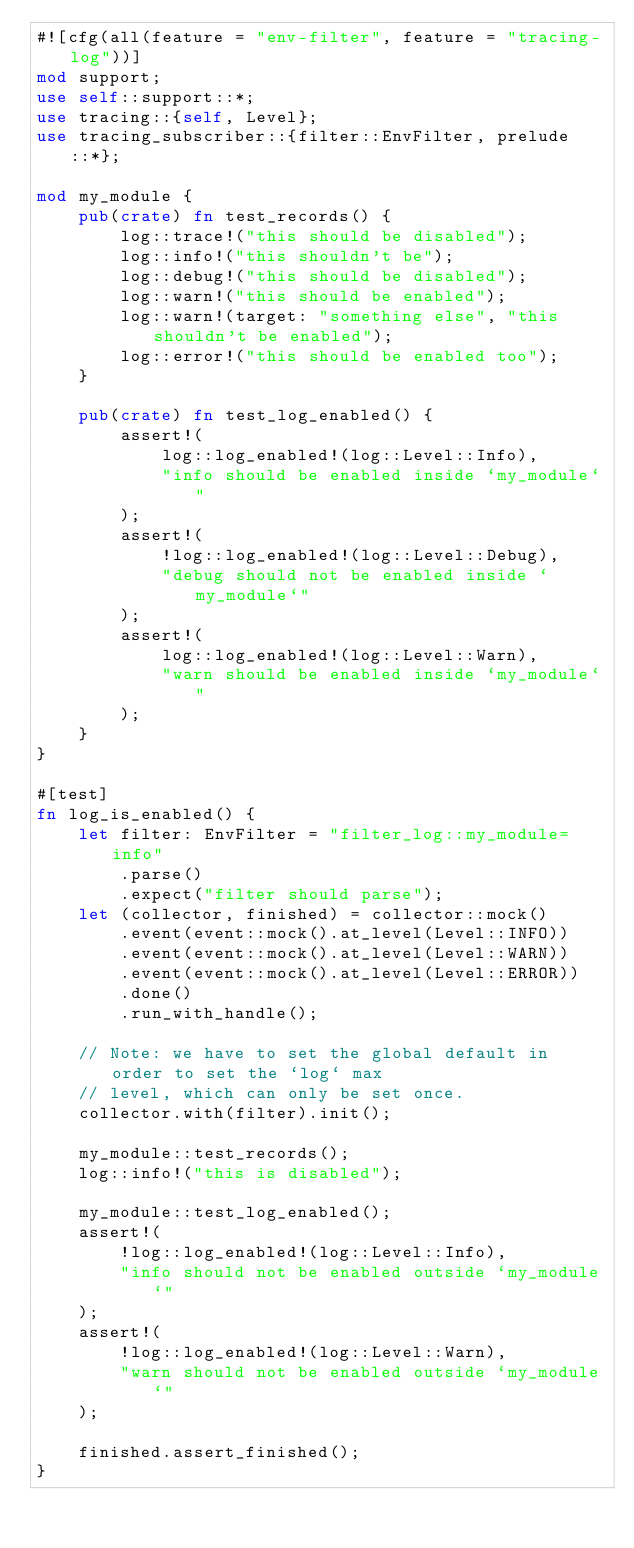Convert code to text. <code><loc_0><loc_0><loc_500><loc_500><_Rust_>#![cfg(all(feature = "env-filter", feature = "tracing-log"))]
mod support;
use self::support::*;
use tracing::{self, Level};
use tracing_subscriber::{filter::EnvFilter, prelude::*};

mod my_module {
    pub(crate) fn test_records() {
        log::trace!("this should be disabled");
        log::info!("this shouldn't be");
        log::debug!("this should be disabled");
        log::warn!("this should be enabled");
        log::warn!(target: "something else", "this shouldn't be enabled");
        log::error!("this should be enabled too");
    }

    pub(crate) fn test_log_enabled() {
        assert!(
            log::log_enabled!(log::Level::Info),
            "info should be enabled inside `my_module`"
        );
        assert!(
            !log::log_enabled!(log::Level::Debug),
            "debug should not be enabled inside `my_module`"
        );
        assert!(
            log::log_enabled!(log::Level::Warn),
            "warn should be enabled inside `my_module`"
        );
    }
}

#[test]
fn log_is_enabled() {
    let filter: EnvFilter = "filter_log::my_module=info"
        .parse()
        .expect("filter should parse");
    let (collector, finished) = collector::mock()
        .event(event::mock().at_level(Level::INFO))
        .event(event::mock().at_level(Level::WARN))
        .event(event::mock().at_level(Level::ERROR))
        .done()
        .run_with_handle();

    // Note: we have to set the global default in order to set the `log` max
    // level, which can only be set once.
    collector.with(filter).init();

    my_module::test_records();
    log::info!("this is disabled");

    my_module::test_log_enabled();
    assert!(
        !log::log_enabled!(log::Level::Info),
        "info should not be enabled outside `my_module`"
    );
    assert!(
        !log::log_enabled!(log::Level::Warn),
        "warn should not be enabled outside `my_module`"
    );

    finished.assert_finished();
}
</code> 